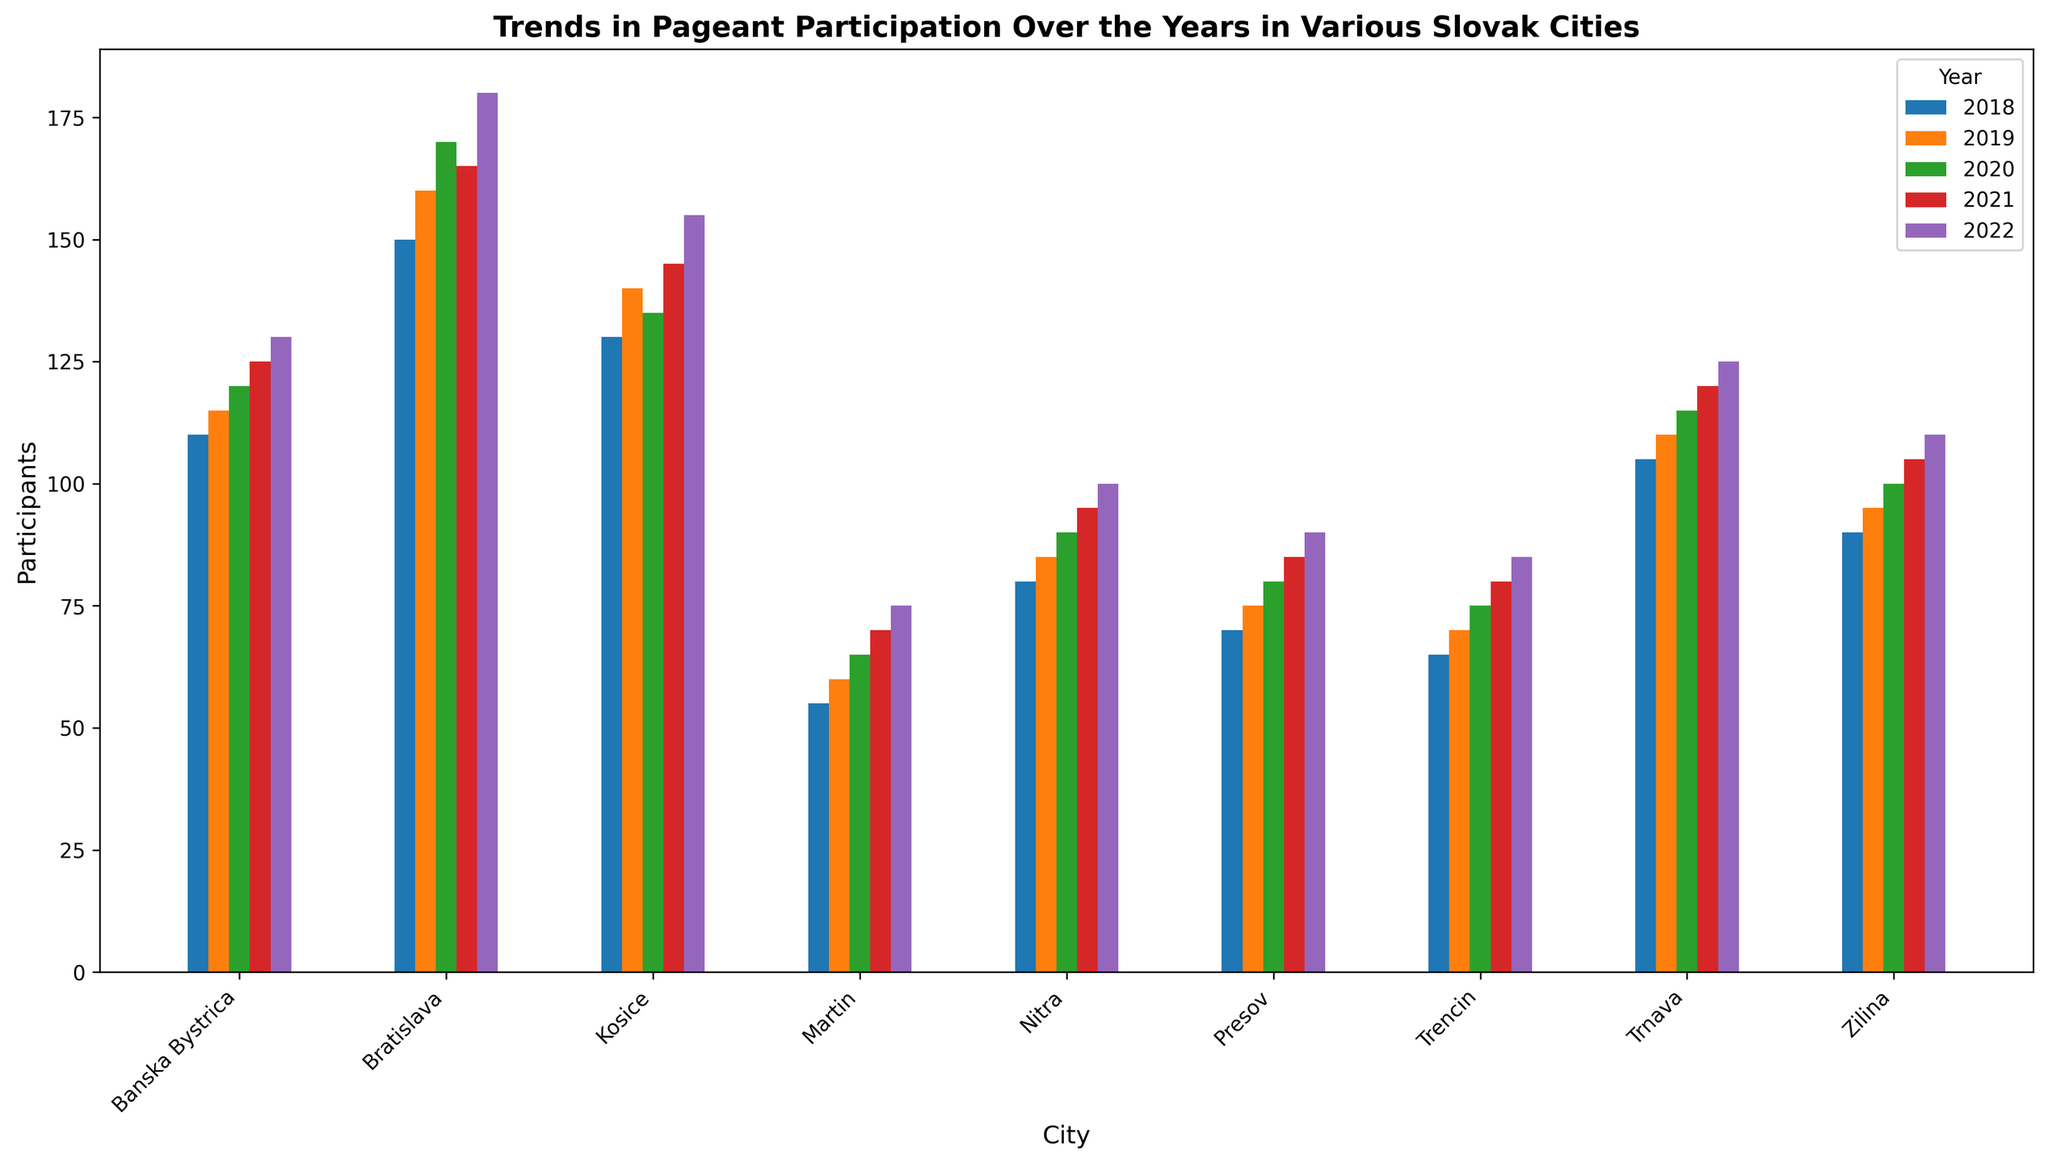Which city had the highest number of participants in 2018? Look at the bars corresponding to 2018 for each city and compare their heights. Bratislava's bar is the tallest.
Answer: Bratislava Which city showed the largest increase in participants from 2018 to 2022? Calculate the difference in the number of participants for each city between 2018 and 2022, then compare these differences. Bratislava increased from 150 to 180 participants, which is the largest increase.
Answer: Bratislava Which city had the smallest number of participants in 2020? Look at the bars corresponding to 2020 for each city and compare their heights. Martin's bar is the shortest.
Answer: Martin What is the average number of participants in Kosice from 2018 to 2022? Sum the number of participants for Kosice from 2018 to 2022 and divide by 5 (the number of years). (130+140+135+145+155) / 5 = 141
Answer: 141 Which two cities had an equal number of participants in 2019? Compare the heights of the bars for different cities in 2019. Trnava and Banska Bystrica both have bars at the same height (115).
Answer: Trnava and Banska Bystrica How many participants were there in total across all cities in 2021? Sum the number of participants from all cities for the year 2021. (165 + 145 + 105 + 95 + 85 + 125 + 120 + 80 + 70) = 990
Answer: 990 Which city had a consistent increase in participants every year from 2018 to 2022? Examine the bars for each city to see which one shows a steady increase in height each year. Zilina shows a consistent yearly increase (90, 95, 100, 105, 110).
Answer: Zilina Was there any year in which Martin had more participants than Trencin? Compare the bars for Martin and Trencin for each year. In 2021, Martin (70) had more participants than Trencin (65).
Answer: 2021 What is the difference in the number of participants between the city with the most and least participants in 2022? Identify the highest and lowest bars for 2022, then calculate the difference. The highest is Bratislava with 180 participants, and the lowest is Martin with 75 participants. The difference is 180 - 75 = 105.
Answer: 105 